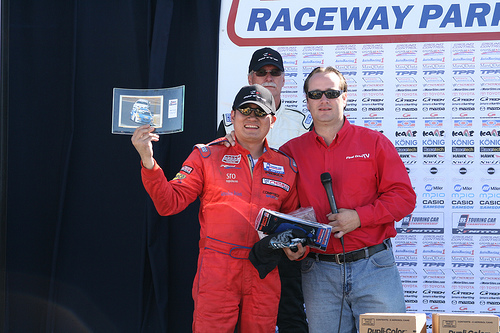<image>
Can you confirm if the human is to the left of the human? Yes. From this viewpoint, the human is positioned to the left side relative to the human. 